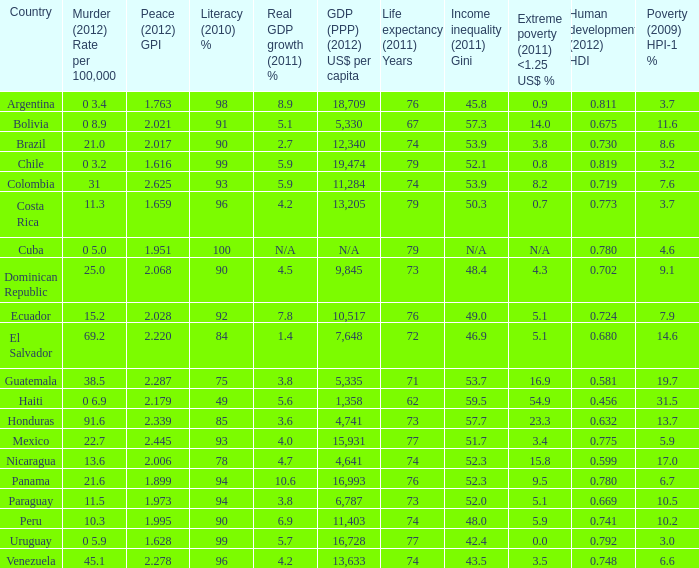Could you parse the entire table as a dict? {'header': ['Country', 'Murder (2012) Rate per 100,000', 'Peace (2012) GPI', 'Literacy (2010) %', 'Real GDP growth (2011) %', 'GDP (PPP) (2012) US$ per capita', 'Life expectancy (2011) Years', 'Income inequality (2011) Gini', 'Extreme poverty (2011) <1.25 US$ %', 'Human development (2012) HDI', 'Poverty (2009) HPI-1 %'], 'rows': [['Argentina', '0 3.4', '1.763', '98', '8.9', '18,709', '76', '45.8', '0.9', '0.811', '3.7'], ['Bolivia', '0 8.9', '2.021', '91', '5.1', '5,330', '67', '57.3', '14.0', '0.675', '11.6'], ['Brazil', '21.0', '2.017', '90', '2.7', '12,340', '74', '53.9', '3.8', '0.730', '8.6'], ['Chile', '0 3.2', '1.616', '99', '5.9', '19,474', '79', '52.1', '0.8', '0.819', '3.2'], ['Colombia', '31', '2.625', '93', '5.9', '11,284', '74', '53.9', '8.2', '0.719', '7.6'], ['Costa Rica', '11.3', '1.659', '96', '4.2', '13,205', '79', '50.3', '0.7', '0.773', '3.7'], ['Cuba', '0 5.0', '1.951', '100', 'N/A', 'N/A', '79', 'N/A', 'N/A', '0.780', '4.6'], ['Dominican Republic', '25.0', '2.068', '90', '4.5', '9,845', '73', '48.4', '4.3', '0.702', '9.1'], ['Ecuador', '15.2', '2.028', '92', '7.8', '10,517', '76', '49.0', '5.1', '0.724', '7.9'], ['El Salvador', '69.2', '2.220', '84', '1.4', '7,648', '72', '46.9', '5.1', '0.680', '14.6'], ['Guatemala', '38.5', '2.287', '75', '3.8', '5,335', '71', '53.7', '16.9', '0.581', '19.7'], ['Haiti', '0 6.9', '2.179', '49', '5.6', '1,358', '62', '59.5', '54.9', '0.456', '31.5'], ['Honduras', '91.6', '2.339', '85', '3.6', '4,741', '73', '57.7', '23.3', '0.632', '13.7'], ['Mexico', '22.7', '2.445', '93', '4.0', '15,931', '77', '51.7', '3.4', '0.775', '5.9'], ['Nicaragua', '13.6', '2.006', '78', '4.7', '4,641', '74', '52.3', '15.8', '0.599', '17.0'], ['Panama', '21.6', '1.899', '94', '10.6', '16,993', '76', '52.3', '9.5', '0.780', '6.7'], ['Paraguay', '11.5', '1.973', '94', '3.8', '6,787', '73', '52.0', '5.1', '0.669', '10.5'], ['Peru', '10.3', '1.995', '90', '6.9', '11,403', '74', '48.0', '5.9', '0.741', '10.2'], ['Uruguay', '0 5.9', '1.628', '99', '5.7', '16,728', '77', '42.4', '0.0', '0.792', '3.0'], ['Venezuela', '45.1', '2.278', '96', '4.2', '13,633', '74', '43.5', '3.5', '0.748', '6.6']]} What is the sum of poverty (2009) HPI-1 % when the GDP (PPP) (2012) US$ per capita of 11,284? 1.0. 